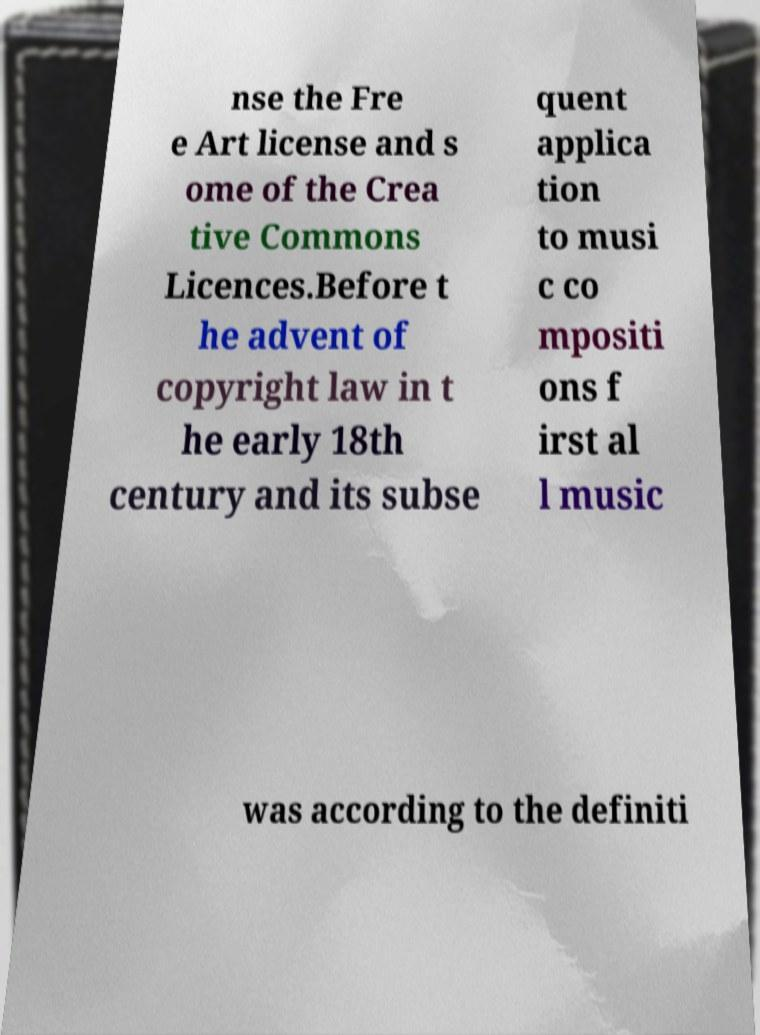Please identify and transcribe the text found in this image. nse the Fre e Art license and s ome of the Crea tive Commons Licences.Before t he advent of copyright law in t he early 18th century and its subse quent applica tion to musi c co mpositi ons f irst al l music was according to the definiti 